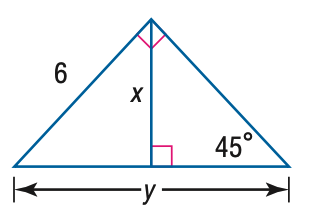Question: Find x.
Choices:
A. 3
B. 3 \sqrt { 2 }
C. 3 \sqrt { 3 }
D. 6 \sqrt { 2 }
Answer with the letter. Answer: B Question: Find y.
Choices:
A. 3 \sqrt { 2 }
B. 6 \sqrt { 2 }
C. 6 \sqrt { 3 }
D. 12
Answer with the letter. Answer: B 